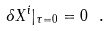<formula> <loc_0><loc_0><loc_500><loc_500>\delta X ^ { i } | _ { \tau = 0 } = 0 \ .</formula> 